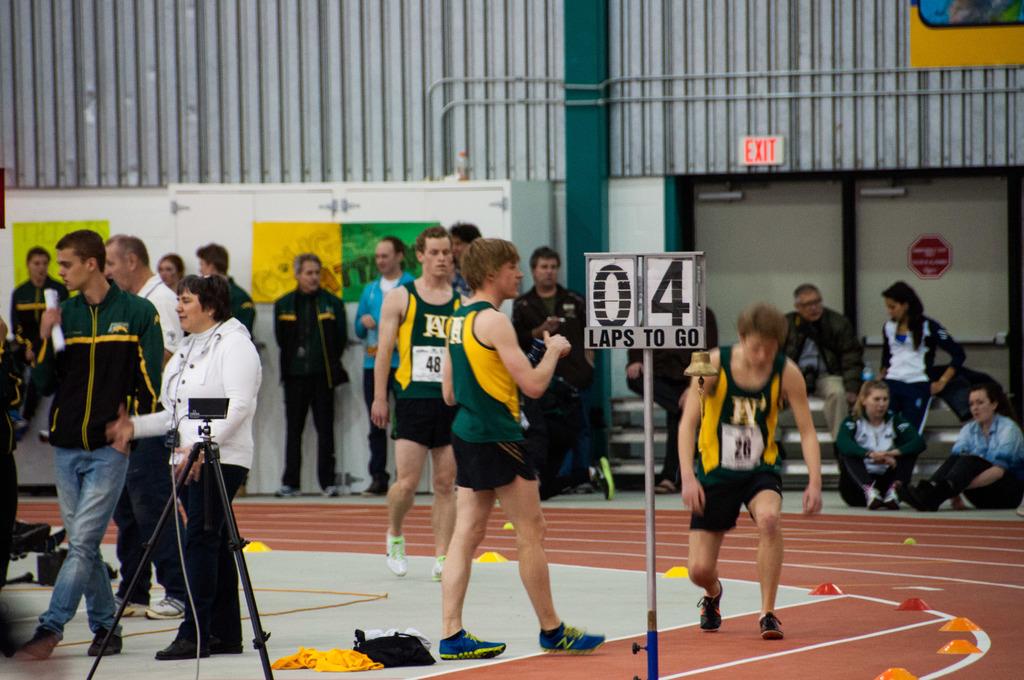How many more laps do they have left?
Provide a short and direct response. 4. How many more laps are there?
Offer a very short reply. 4. 